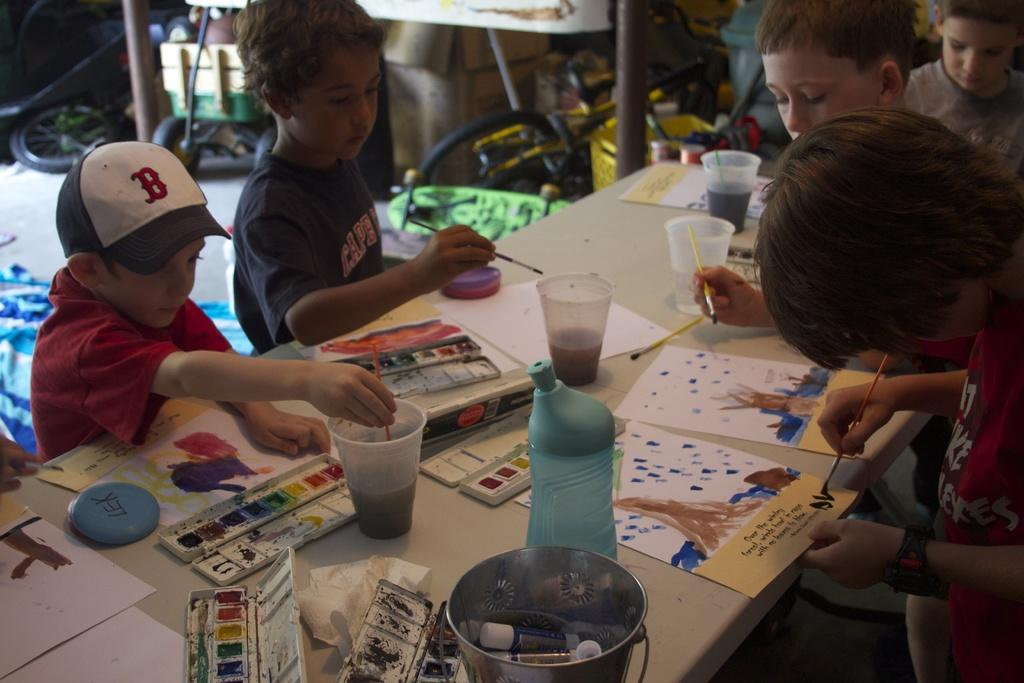How many kids are in the image? There are several kids in the image. What are the kids doing in the image? The kids are painting. Where are the kids located in the image? The kids are at a table. What items can be seen on the table in the image? There are painting equipment on the table. What type of honey is being used by the kids in the image? There is no honey present in the image; the kids are painting. What news story are the kids discussing while painting in the image? There is no indication in the image that the kids are discussing any news stories while painting. 